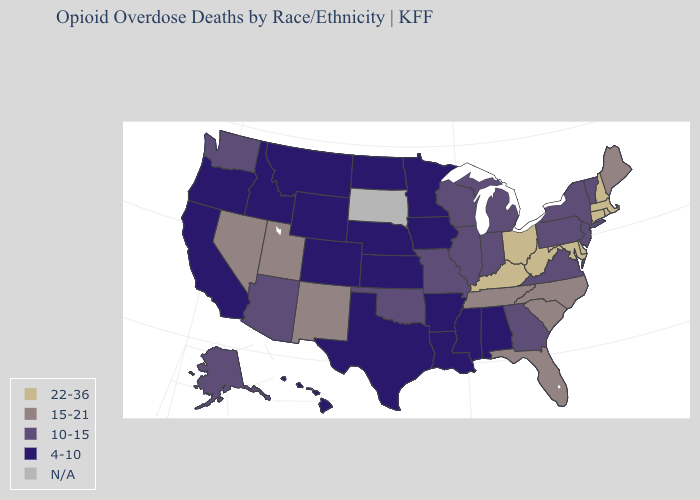Name the states that have a value in the range 4-10?
Concise answer only. Alabama, Arkansas, California, Colorado, Hawaii, Idaho, Iowa, Kansas, Louisiana, Minnesota, Mississippi, Montana, Nebraska, North Dakota, Oregon, Texas, Wyoming. Name the states that have a value in the range N/A?
Quick response, please. South Dakota. Name the states that have a value in the range 22-36?
Quick response, please. Connecticut, Delaware, Kentucky, Maryland, Massachusetts, New Hampshire, Ohio, Rhode Island, West Virginia. Name the states that have a value in the range N/A?
Be succinct. South Dakota. What is the highest value in states that border Wisconsin?
Quick response, please. 10-15. Name the states that have a value in the range N/A?
Give a very brief answer. South Dakota. Which states have the lowest value in the USA?
Give a very brief answer. Alabama, Arkansas, California, Colorado, Hawaii, Idaho, Iowa, Kansas, Louisiana, Minnesota, Mississippi, Montana, Nebraska, North Dakota, Oregon, Texas, Wyoming. Which states have the highest value in the USA?
Write a very short answer. Connecticut, Delaware, Kentucky, Maryland, Massachusetts, New Hampshire, Ohio, Rhode Island, West Virginia. Name the states that have a value in the range 22-36?
Be succinct. Connecticut, Delaware, Kentucky, Maryland, Massachusetts, New Hampshire, Ohio, Rhode Island, West Virginia. Among the states that border Louisiana , which have the lowest value?
Concise answer only. Arkansas, Mississippi, Texas. Does Virginia have the highest value in the South?
Give a very brief answer. No. Name the states that have a value in the range 10-15?
Write a very short answer. Alaska, Arizona, Georgia, Illinois, Indiana, Michigan, Missouri, New Jersey, New York, Oklahoma, Pennsylvania, Vermont, Virginia, Washington, Wisconsin. 